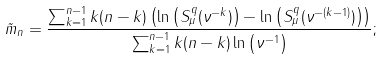<formula> <loc_0><loc_0><loc_500><loc_500>\tilde { m } _ { n } = \frac { \sum _ { k = 1 } ^ { n - 1 } k ( n - k ) \left ( \ln \left ( S _ { \mu } ^ { q } ( \nu ^ { - k } ) \right ) - \ln \left ( S _ { \mu } ^ { q } ( \nu ^ { - ( k - 1 ) } ) \right ) \right ) } { \sum _ { k = 1 } ^ { n - 1 } k ( n - k ) \ln \left ( \nu ^ { - 1 } \right ) } ;</formula> 